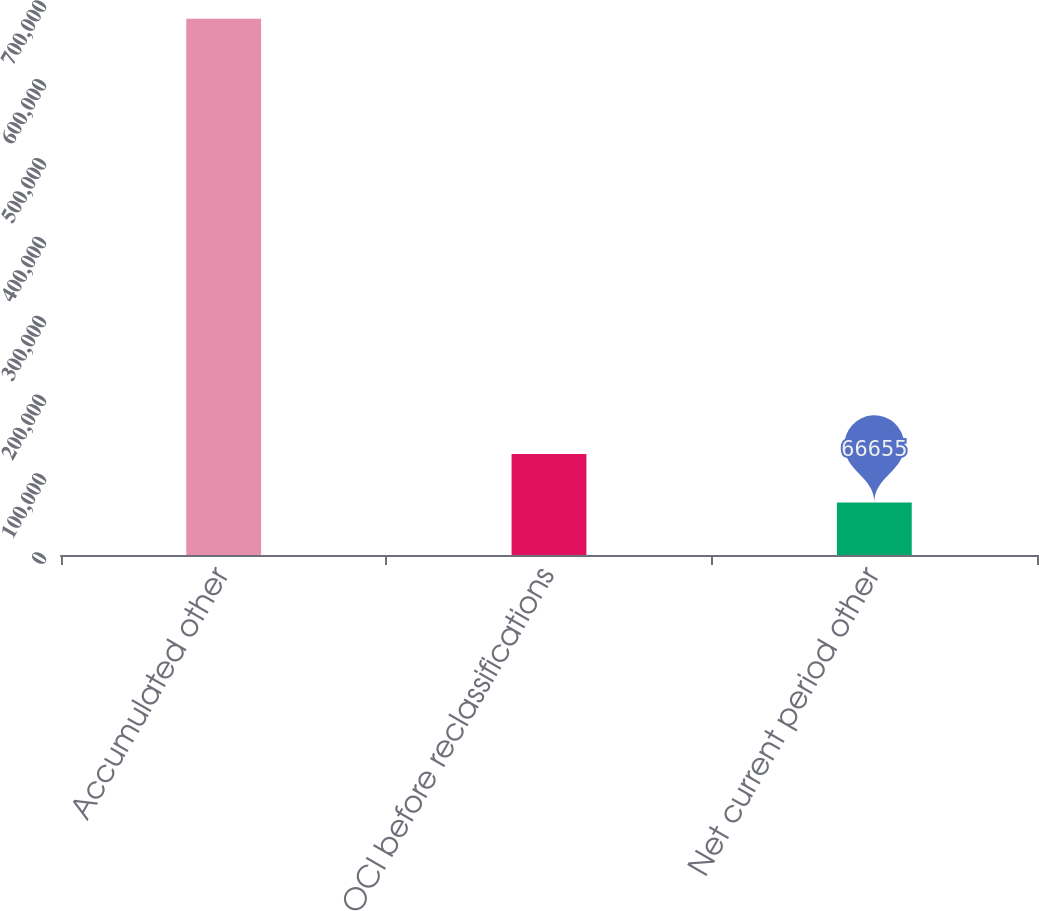<chart> <loc_0><loc_0><loc_500><loc_500><bar_chart><fcel>Accumulated other<fcel>OCI before reclassifications<fcel>Net current period other<nl><fcel>680095<fcel>127999<fcel>66655<nl></chart> 